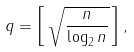<formula> <loc_0><loc_0><loc_500><loc_500>q = \left [ \, \sqrt { \frac { n } { \log _ { 2 } n } } \, \right ] ,</formula> 